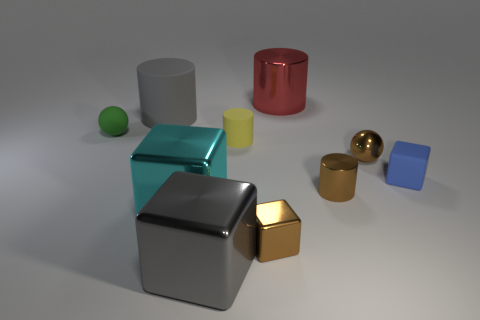What is the color of the tiny rubber cylinder?
Give a very brief answer. Yellow. What is the color of the tiny object behind the tiny cylinder behind the tiny matte cube?
Your response must be concise. Green. Do the tiny metallic cylinder and the matte thing that is behind the green matte object have the same color?
Provide a succinct answer. No. How many gray matte things are to the right of the gray thing that is behind the cube on the right side of the small shiny block?
Ensure brevity in your answer.  0. Are there any small brown cylinders to the left of the gray shiny thing?
Offer a terse response. No. Are there any other things that are the same color as the tiny shiny cylinder?
Make the answer very short. Yes. What number of cubes are either large cyan metal things or big metallic things?
Offer a terse response. 2. What number of objects are both right of the brown metal block and to the left of the gray metallic cube?
Offer a terse response. 0. Are there an equal number of gray shiny blocks left of the small brown metallic sphere and tiny brown objects that are in front of the blue rubber block?
Offer a terse response. No. There is a thing behind the big gray cylinder; is it the same shape as the yellow rubber thing?
Ensure brevity in your answer.  Yes. 